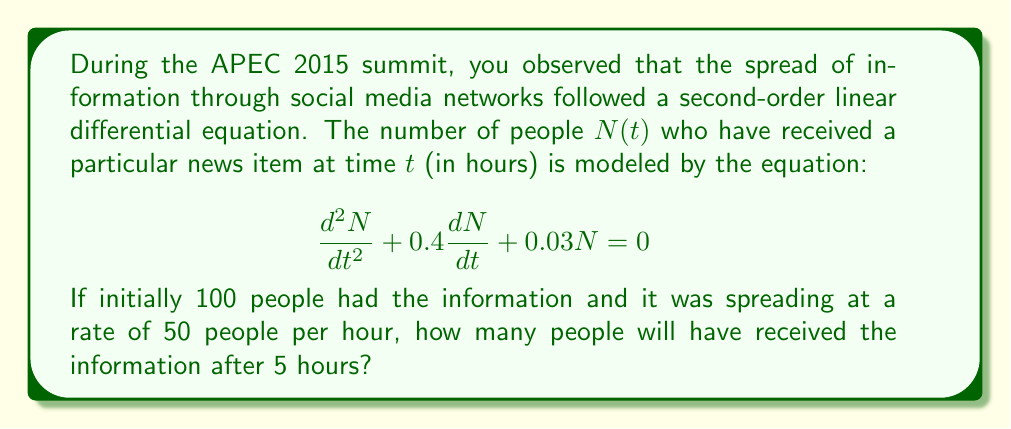Solve this math problem. To solve this problem, we need to follow these steps:

1) First, we need to solve the characteristic equation of the given differential equation:

   $$r^2 + 0.4r + 0.03 = 0$$

2) Using the quadratic formula, we get:

   $$r = \frac{-0.4 \pm \sqrt{0.4^2 - 4(1)(0.03)}}{2(1)} = \frac{-0.4 \pm \sqrt{0.16 - 0.12}}{2} = \frac{-0.4 \pm \sqrt{0.04}}{2} = \frac{-0.4 \pm 0.2}{2}$$

3) This gives us two roots:

   $$r_1 = -0.3 \text{ and } r_2 = -0.1$$

4) The general solution to the differential equation is therefore:

   $$N(t) = C_1e^{-0.3t} + C_2e^{-0.1t}$$

5) We need to use the initial conditions to find $C_1$ and $C_2$. We know that:

   At $t=0$, $N(0) = 100$ and $N'(0) = 50$

6) From $N(0) = 100$:

   $$100 = C_1 + C_2$$

7) From $N'(0) = 50$:

   $$50 = -0.3C_1 - 0.1C_2$$

8) Solving these simultaneous equations:

   $$C_1 = 250 \text{ and } C_2 = -150$$

9) Therefore, the particular solution is:

   $$N(t) = 250e^{-0.3t} - 150e^{-0.1t}$$

10) To find $N(5)$, we simply substitute $t=5$:

    $$N(5) = 250e^{-0.3(5)} - 150e^{-0.1(5)} = 250e^{-1.5} - 150e^{-0.5}$$

11) Calculating this:

    $$N(5) \approx 250(0.2231) - 150(0.6065) \approx 55.775 - 90.975 \approx -35.2$$

12) Since we can't have a negative number of people, we round this up to 0.
Answer: After 5 hours, approximately 0 people will have received the information. The model predicts a negative number, which is not physically meaningful in this context, so we interpret this as the information not spreading effectively. 